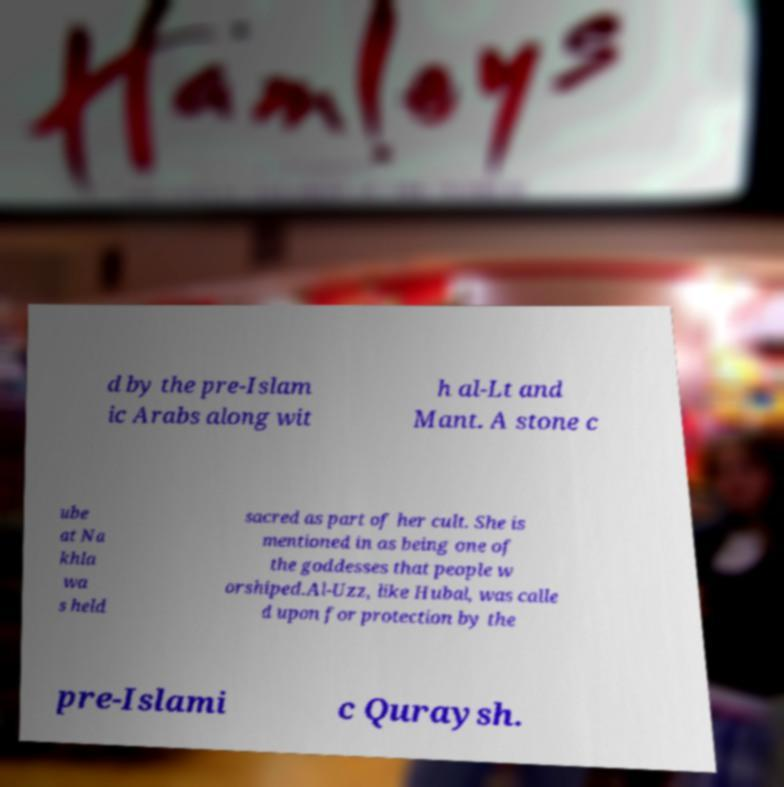Could you extract and type out the text from this image? d by the pre-Islam ic Arabs along wit h al-Lt and Mant. A stone c ube at Na khla wa s held sacred as part of her cult. She is mentioned in as being one of the goddesses that people w orshiped.Al-Uzz, like Hubal, was calle d upon for protection by the pre-Islami c Quraysh. 